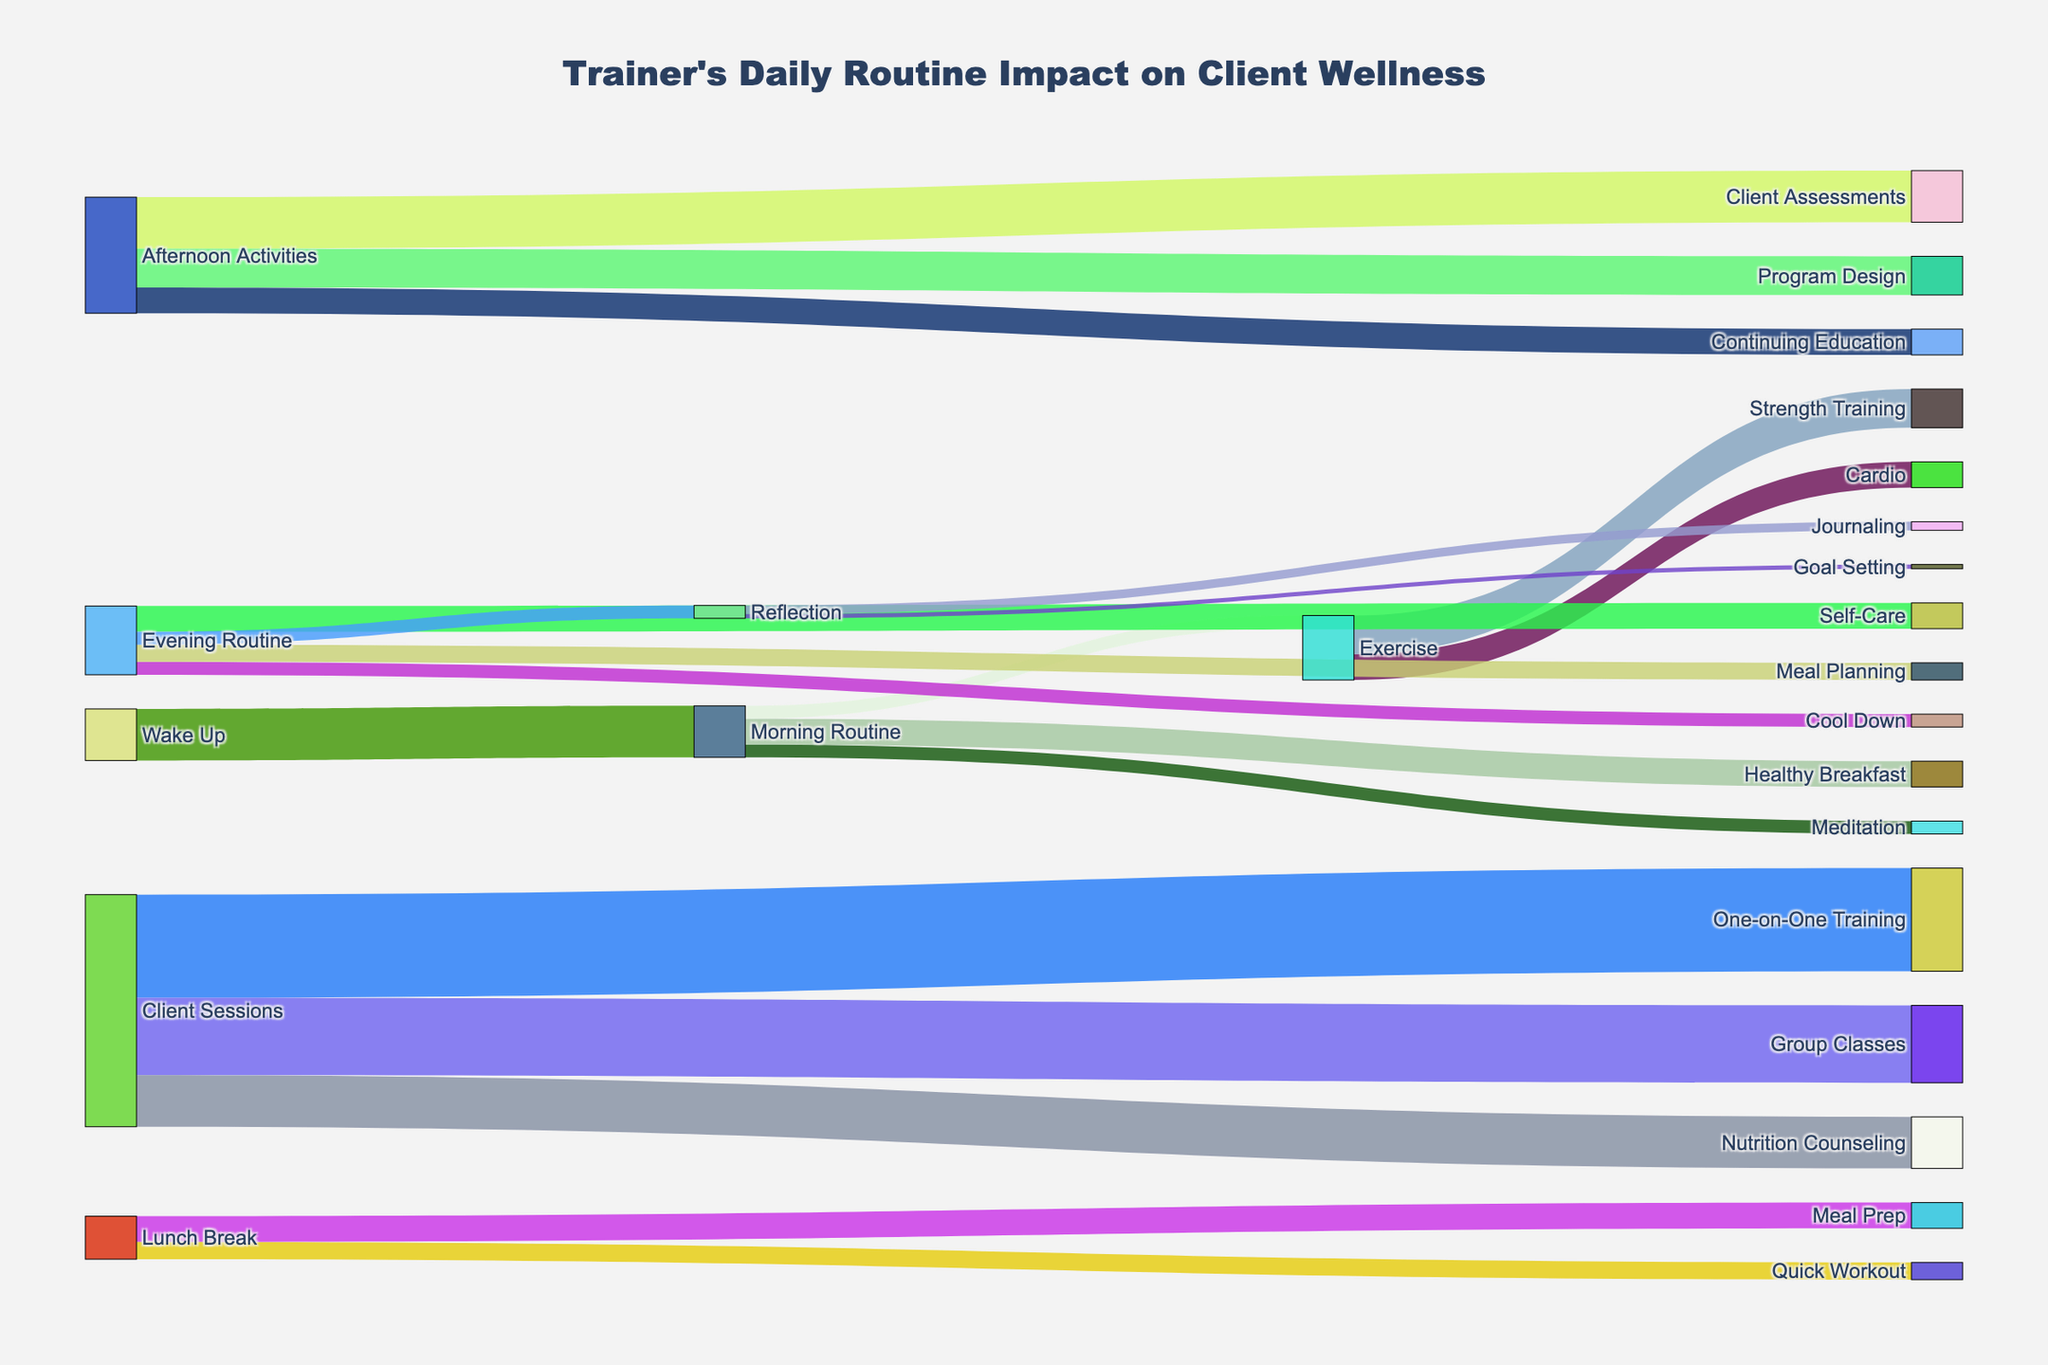What's the title of the figure? The title of the figure is prominently displayed at the top.
Answer: Trainer's Daily Routine Impact on Client Wellness How much time is allocated for "Meditation" during the "Morning Routine"? Trace the path from "Morning Routine" to "Meditation" and check the value indicated.
Answer: 15 minutes Which activity takes up the majority of the "Client Sessions"? Compare the values of "One-on-One Training", "Group Classes", and "Nutrition Counseling" under the "Client Sessions" category.
Answer: One-on-One Training How much total time is spent on "Exercise"? Sum the values of "Exercise" activities under "Morning Routine" and the specific exercises (Cardio and Strength Training).
Answer: 90 minutes What is the flow from "Evening Routine" to "Self-Care"? Trace the path from "Evening Routine" and locate "Self-Care" to identify the value.
Answer: 30 minutes Which has a greater duration, "Cardio" or "Strength Training"? Compare the values associated with both "Cardio" and "Strength Training" stemming from "Exercise".
Answer: Strength Training How does the time spent on "Program Design" compare to "Continuing Education"? Find the values associated with both "Program Design" and "Continuing Education" under "Afternoon Activities" and compare them.
Answer: Program Design takes more time What is the total duration spent on "Morning Routine" activities? Add the time durations for "Meditation", "Healthy Breakfast", and "Exercise" under "Morning Routine".
Answer: 60 minutes How does the time allocated to "Meal Planning" in "Evening Routine" compare to "Journaling" in "Reflection"? Compare the values for "Meal Planning" under "Evening Routine" and "Journaling" under "Reflection".
Answer: Meal Planning What follows directly after "Reflection"? Identify the target activities directly stemming from "Reflection".
Answer: Journaling and Goal Setting 